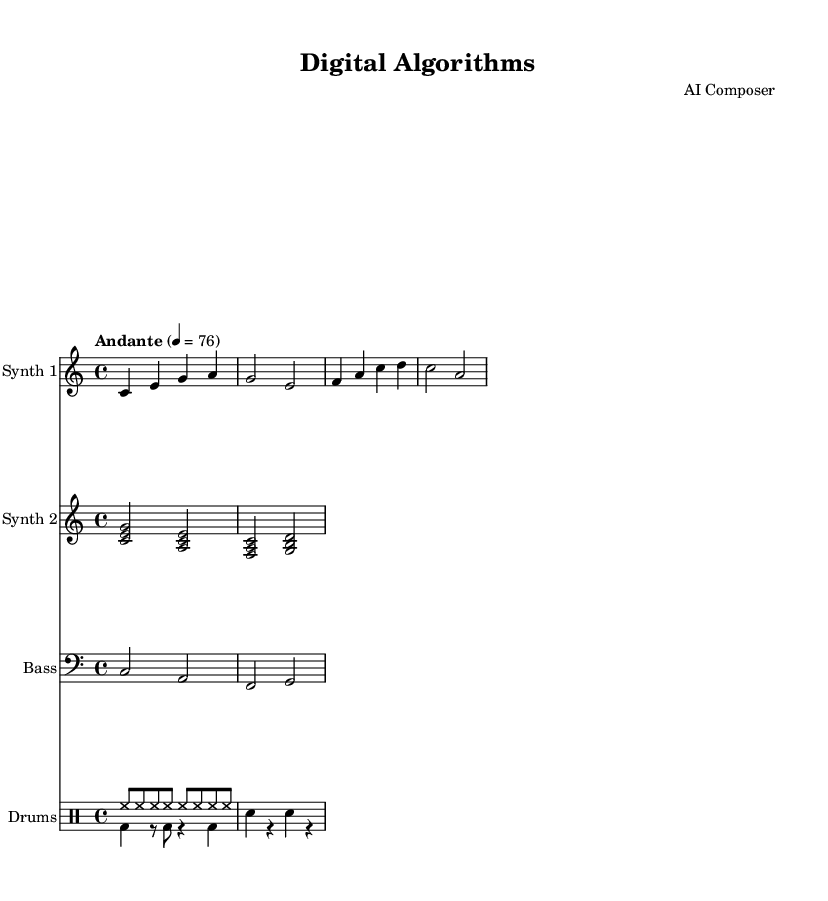What is the key signature of this music? The key signature is C major, which has no sharps or flats indicated on the staff.
Answer: C major What is the time signature of this piece? The time signature is found at the beginning of the score and shows four beats in each measure, indicated by the fraction 4/4.
Answer: 4/4 What is the tempo marking? The tempo marking is included in the header and specifies the speed at which the piece should be played, which is Andante at a quarter note equals 76 beats per minute.
Answer: Andante 76 How many voices are present in the drum section? The drum section consists of two distinct parts, indicated by two different voices labeled as voice one and voice two, which play separate patterns.
Answer: 2 Which instrument has the lowest pitch? The bass is designated with a bass clef, which typically notates music in a lower register compared to other instruments in this score, particularly the synths.
Answer: Bass What rhythmic pattern is used for the hi-hat? The rhythmic pattern for the hi-hat is represented by eight eighth notes played in succession, indicating a continuous rhythm throughout that section.
Answer: Eight eighth notes What is the first note of Synth 1? The first note appears in the synth one part, which starts with the note C in the second octave, noted at the start of the staff.
Answer: C 